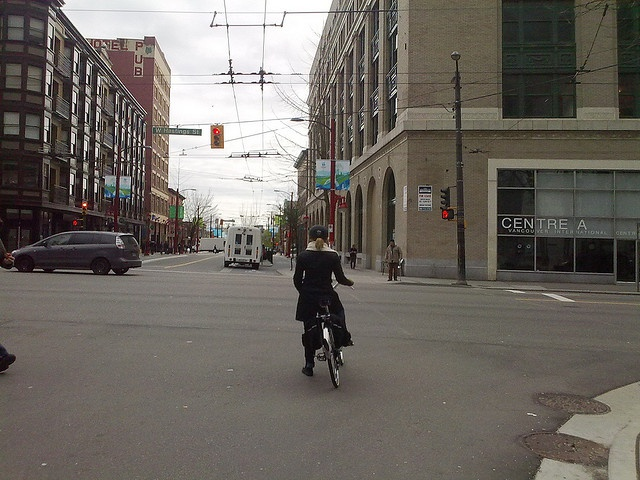Describe the objects in this image and their specific colors. I can see people in black, gray, and darkgray tones, car in black, gray, and darkgray tones, truck in black, darkgray, and gray tones, bicycle in black, gray, darkgray, and lightgray tones, and people in black and gray tones in this image. 